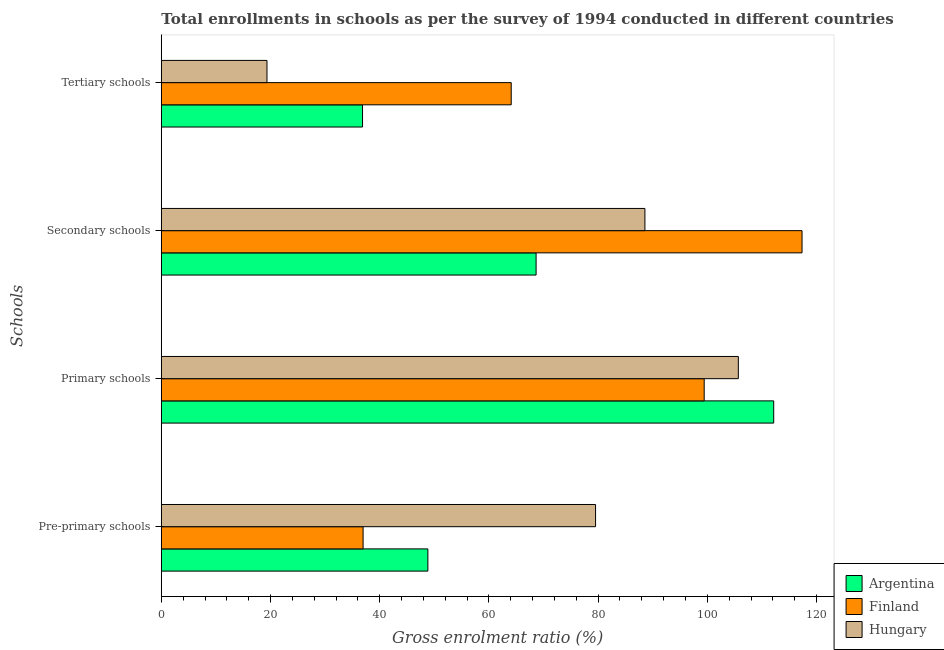How many different coloured bars are there?
Ensure brevity in your answer.  3. Are the number of bars per tick equal to the number of legend labels?
Your answer should be compact. Yes. How many bars are there on the 1st tick from the top?
Keep it short and to the point. 3. What is the label of the 4th group of bars from the top?
Offer a terse response. Pre-primary schools. What is the gross enrolment ratio in primary schools in Hungary?
Your answer should be compact. 105.68. Across all countries, what is the maximum gross enrolment ratio in primary schools?
Offer a terse response. 112.15. Across all countries, what is the minimum gross enrolment ratio in primary schools?
Your response must be concise. 99.42. In which country was the gross enrolment ratio in tertiary schools maximum?
Keep it short and to the point. Finland. In which country was the gross enrolment ratio in tertiary schools minimum?
Make the answer very short. Hungary. What is the total gross enrolment ratio in pre-primary schools in the graph?
Your response must be concise. 165.3. What is the difference between the gross enrolment ratio in tertiary schools in Finland and that in Hungary?
Make the answer very short. 44.73. What is the difference between the gross enrolment ratio in pre-primary schools in Hungary and the gross enrolment ratio in primary schools in Argentina?
Keep it short and to the point. -32.62. What is the average gross enrolment ratio in secondary schools per country?
Offer a terse response. 91.51. What is the difference between the gross enrolment ratio in secondary schools and gross enrolment ratio in pre-primary schools in Argentina?
Make the answer very short. 19.82. What is the ratio of the gross enrolment ratio in secondary schools in Hungary to that in Argentina?
Provide a short and direct response. 1.29. Is the difference between the gross enrolment ratio in primary schools in Finland and Hungary greater than the difference between the gross enrolment ratio in tertiary schools in Finland and Hungary?
Your answer should be compact. No. What is the difference between the highest and the second highest gross enrolment ratio in secondary schools?
Ensure brevity in your answer.  28.78. What is the difference between the highest and the lowest gross enrolment ratio in tertiary schools?
Give a very brief answer. 44.73. Is it the case that in every country, the sum of the gross enrolment ratio in pre-primary schools and gross enrolment ratio in secondary schools is greater than the sum of gross enrolment ratio in tertiary schools and gross enrolment ratio in primary schools?
Provide a succinct answer. Yes. What does the 3rd bar from the top in Pre-primary schools represents?
Keep it short and to the point. Argentina. What does the 1st bar from the bottom in Tertiary schools represents?
Offer a terse response. Argentina. How many bars are there?
Ensure brevity in your answer.  12. What is the difference between two consecutive major ticks on the X-axis?
Offer a very short reply. 20. Are the values on the major ticks of X-axis written in scientific E-notation?
Give a very brief answer. No. Does the graph contain any zero values?
Ensure brevity in your answer.  No. Does the graph contain grids?
Keep it short and to the point. No. How are the legend labels stacked?
Make the answer very short. Vertical. What is the title of the graph?
Provide a succinct answer. Total enrollments in schools as per the survey of 1994 conducted in different countries. Does "Middle East & North Africa (developing only)" appear as one of the legend labels in the graph?
Offer a very short reply. No. What is the label or title of the Y-axis?
Offer a terse response. Schools. What is the Gross enrolment ratio (%) in Argentina in Pre-primary schools?
Your response must be concise. 48.82. What is the Gross enrolment ratio (%) of Finland in Pre-primary schools?
Provide a short and direct response. 36.95. What is the Gross enrolment ratio (%) in Hungary in Pre-primary schools?
Your answer should be compact. 79.53. What is the Gross enrolment ratio (%) in Argentina in Primary schools?
Offer a very short reply. 112.15. What is the Gross enrolment ratio (%) of Finland in Primary schools?
Give a very brief answer. 99.42. What is the Gross enrolment ratio (%) in Hungary in Primary schools?
Offer a terse response. 105.68. What is the Gross enrolment ratio (%) in Argentina in Secondary schools?
Give a very brief answer. 68.64. What is the Gross enrolment ratio (%) of Finland in Secondary schools?
Your answer should be compact. 117.34. What is the Gross enrolment ratio (%) of Hungary in Secondary schools?
Offer a terse response. 88.56. What is the Gross enrolment ratio (%) in Argentina in Tertiary schools?
Your response must be concise. 36.85. What is the Gross enrolment ratio (%) of Finland in Tertiary schools?
Your answer should be compact. 64.08. What is the Gross enrolment ratio (%) of Hungary in Tertiary schools?
Provide a succinct answer. 19.35. Across all Schools, what is the maximum Gross enrolment ratio (%) in Argentina?
Offer a very short reply. 112.15. Across all Schools, what is the maximum Gross enrolment ratio (%) of Finland?
Your answer should be compact. 117.34. Across all Schools, what is the maximum Gross enrolment ratio (%) in Hungary?
Your answer should be very brief. 105.68. Across all Schools, what is the minimum Gross enrolment ratio (%) in Argentina?
Offer a very short reply. 36.85. Across all Schools, what is the minimum Gross enrolment ratio (%) in Finland?
Give a very brief answer. 36.95. Across all Schools, what is the minimum Gross enrolment ratio (%) of Hungary?
Provide a short and direct response. 19.35. What is the total Gross enrolment ratio (%) in Argentina in the graph?
Your answer should be very brief. 266.46. What is the total Gross enrolment ratio (%) of Finland in the graph?
Your answer should be very brief. 317.79. What is the total Gross enrolment ratio (%) in Hungary in the graph?
Your answer should be very brief. 293.12. What is the difference between the Gross enrolment ratio (%) in Argentina in Pre-primary schools and that in Primary schools?
Your answer should be compact. -63.33. What is the difference between the Gross enrolment ratio (%) of Finland in Pre-primary schools and that in Primary schools?
Offer a very short reply. -62.47. What is the difference between the Gross enrolment ratio (%) in Hungary in Pre-primary schools and that in Primary schools?
Ensure brevity in your answer.  -26.15. What is the difference between the Gross enrolment ratio (%) in Argentina in Pre-primary schools and that in Secondary schools?
Provide a short and direct response. -19.82. What is the difference between the Gross enrolment ratio (%) of Finland in Pre-primary schools and that in Secondary schools?
Offer a terse response. -80.39. What is the difference between the Gross enrolment ratio (%) of Hungary in Pre-primary schools and that in Secondary schools?
Offer a terse response. -9.04. What is the difference between the Gross enrolment ratio (%) of Argentina in Pre-primary schools and that in Tertiary schools?
Your response must be concise. 11.97. What is the difference between the Gross enrolment ratio (%) in Finland in Pre-primary schools and that in Tertiary schools?
Offer a very short reply. -27.13. What is the difference between the Gross enrolment ratio (%) in Hungary in Pre-primary schools and that in Tertiary schools?
Make the answer very short. 60.18. What is the difference between the Gross enrolment ratio (%) in Argentina in Primary schools and that in Secondary schools?
Your answer should be compact. 43.51. What is the difference between the Gross enrolment ratio (%) in Finland in Primary schools and that in Secondary schools?
Keep it short and to the point. -17.92. What is the difference between the Gross enrolment ratio (%) in Hungary in Primary schools and that in Secondary schools?
Offer a terse response. 17.11. What is the difference between the Gross enrolment ratio (%) in Argentina in Primary schools and that in Tertiary schools?
Keep it short and to the point. 75.3. What is the difference between the Gross enrolment ratio (%) of Finland in Primary schools and that in Tertiary schools?
Make the answer very short. 35.34. What is the difference between the Gross enrolment ratio (%) of Hungary in Primary schools and that in Tertiary schools?
Make the answer very short. 86.33. What is the difference between the Gross enrolment ratio (%) of Argentina in Secondary schools and that in Tertiary schools?
Your answer should be compact. 31.79. What is the difference between the Gross enrolment ratio (%) in Finland in Secondary schools and that in Tertiary schools?
Keep it short and to the point. 53.26. What is the difference between the Gross enrolment ratio (%) in Hungary in Secondary schools and that in Tertiary schools?
Your answer should be very brief. 69.21. What is the difference between the Gross enrolment ratio (%) of Argentina in Pre-primary schools and the Gross enrolment ratio (%) of Finland in Primary schools?
Ensure brevity in your answer.  -50.6. What is the difference between the Gross enrolment ratio (%) of Argentina in Pre-primary schools and the Gross enrolment ratio (%) of Hungary in Primary schools?
Provide a short and direct response. -56.86. What is the difference between the Gross enrolment ratio (%) of Finland in Pre-primary schools and the Gross enrolment ratio (%) of Hungary in Primary schools?
Provide a short and direct response. -68.72. What is the difference between the Gross enrolment ratio (%) in Argentina in Pre-primary schools and the Gross enrolment ratio (%) in Finland in Secondary schools?
Your response must be concise. -68.52. What is the difference between the Gross enrolment ratio (%) of Argentina in Pre-primary schools and the Gross enrolment ratio (%) of Hungary in Secondary schools?
Offer a very short reply. -39.75. What is the difference between the Gross enrolment ratio (%) in Finland in Pre-primary schools and the Gross enrolment ratio (%) in Hungary in Secondary schools?
Your answer should be compact. -51.61. What is the difference between the Gross enrolment ratio (%) in Argentina in Pre-primary schools and the Gross enrolment ratio (%) in Finland in Tertiary schools?
Make the answer very short. -15.26. What is the difference between the Gross enrolment ratio (%) in Argentina in Pre-primary schools and the Gross enrolment ratio (%) in Hungary in Tertiary schools?
Your answer should be compact. 29.47. What is the difference between the Gross enrolment ratio (%) in Finland in Pre-primary schools and the Gross enrolment ratio (%) in Hungary in Tertiary schools?
Provide a short and direct response. 17.6. What is the difference between the Gross enrolment ratio (%) in Argentina in Primary schools and the Gross enrolment ratio (%) in Finland in Secondary schools?
Provide a succinct answer. -5.19. What is the difference between the Gross enrolment ratio (%) in Argentina in Primary schools and the Gross enrolment ratio (%) in Hungary in Secondary schools?
Offer a terse response. 23.59. What is the difference between the Gross enrolment ratio (%) in Finland in Primary schools and the Gross enrolment ratio (%) in Hungary in Secondary schools?
Provide a short and direct response. 10.86. What is the difference between the Gross enrolment ratio (%) of Argentina in Primary schools and the Gross enrolment ratio (%) of Finland in Tertiary schools?
Make the answer very short. 48.07. What is the difference between the Gross enrolment ratio (%) in Argentina in Primary schools and the Gross enrolment ratio (%) in Hungary in Tertiary schools?
Make the answer very short. 92.8. What is the difference between the Gross enrolment ratio (%) in Finland in Primary schools and the Gross enrolment ratio (%) in Hungary in Tertiary schools?
Give a very brief answer. 80.07. What is the difference between the Gross enrolment ratio (%) in Argentina in Secondary schools and the Gross enrolment ratio (%) in Finland in Tertiary schools?
Ensure brevity in your answer.  4.56. What is the difference between the Gross enrolment ratio (%) of Argentina in Secondary schools and the Gross enrolment ratio (%) of Hungary in Tertiary schools?
Make the answer very short. 49.28. What is the difference between the Gross enrolment ratio (%) in Finland in Secondary schools and the Gross enrolment ratio (%) in Hungary in Tertiary schools?
Give a very brief answer. 97.99. What is the average Gross enrolment ratio (%) in Argentina per Schools?
Your response must be concise. 66.61. What is the average Gross enrolment ratio (%) of Finland per Schools?
Offer a terse response. 79.45. What is the average Gross enrolment ratio (%) in Hungary per Schools?
Provide a short and direct response. 73.28. What is the difference between the Gross enrolment ratio (%) in Argentina and Gross enrolment ratio (%) in Finland in Pre-primary schools?
Your response must be concise. 11.87. What is the difference between the Gross enrolment ratio (%) of Argentina and Gross enrolment ratio (%) of Hungary in Pre-primary schools?
Give a very brief answer. -30.71. What is the difference between the Gross enrolment ratio (%) in Finland and Gross enrolment ratio (%) in Hungary in Pre-primary schools?
Give a very brief answer. -42.58. What is the difference between the Gross enrolment ratio (%) in Argentina and Gross enrolment ratio (%) in Finland in Primary schools?
Keep it short and to the point. 12.73. What is the difference between the Gross enrolment ratio (%) of Argentina and Gross enrolment ratio (%) of Hungary in Primary schools?
Offer a very short reply. 6.47. What is the difference between the Gross enrolment ratio (%) of Finland and Gross enrolment ratio (%) of Hungary in Primary schools?
Make the answer very short. -6.26. What is the difference between the Gross enrolment ratio (%) in Argentina and Gross enrolment ratio (%) in Finland in Secondary schools?
Give a very brief answer. -48.7. What is the difference between the Gross enrolment ratio (%) of Argentina and Gross enrolment ratio (%) of Hungary in Secondary schools?
Your answer should be compact. -19.93. What is the difference between the Gross enrolment ratio (%) of Finland and Gross enrolment ratio (%) of Hungary in Secondary schools?
Give a very brief answer. 28.78. What is the difference between the Gross enrolment ratio (%) of Argentina and Gross enrolment ratio (%) of Finland in Tertiary schools?
Give a very brief answer. -27.23. What is the difference between the Gross enrolment ratio (%) of Argentina and Gross enrolment ratio (%) of Hungary in Tertiary schools?
Your answer should be very brief. 17.5. What is the difference between the Gross enrolment ratio (%) of Finland and Gross enrolment ratio (%) of Hungary in Tertiary schools?
Ensure brevity in your answer.  44.73. What is the ratio of the Gross enrolment ratio (%) of Argentina in Pre-primary schools to that in Primary schools?
Your answer should be very brief. 0.44. What is the ratio of the Gross enrolment ratio (%) in Finland in Pre-primary schools to that in Primary schools?
Your answer should be compact. 0.37. What is the ratio of the Gross enrolment ratio (%) in Hungary in Pre-primary schools to that in Primary schools?
Offer a terse response. 0.75. What is the ratio of the Gross enrolment ratio (%) of Argentina in Pre-primary schools to that in Secondary schools?
Your answer should be very brief. 0.71. What is the ratio of the Gross enrolment ratio (%) in Finland in Pre-primary schools to that in Secondary schools?
Your response must be concise. 0.31. What is the ratio of the Gross enrolment ratio (%) of Hungary in Pre-primary schools to that in Secondary schools?
Give a very brief answer. 0.9. What is the ratio of the Gross enrolment ratio (%) in Argentina in Pre-primary schools to that in Tertiary schools?
Your response must be concise. 1.32. What is the ratio of the Gross enrolment ratio (%) of Finland in Pre-primary schools to that in Tertiary schools?
Give a very brief answer. 0.58. What is the ratio of the Gross enrolment ratio (%) in Hungary in Pre-primary schools to that in Tertiary schools?
Your response must be concise. 4.11. What is the ratio of the Gross enrolment ratio (%) of Argentina in Primary schools to that in Secondary schools?
Provide a short and direct response. 1.63. What is the ratio of the Gross enrolment ratio (%) in Finland in Primary schools to that in Secondary schools?
Your answer should be compact. 0.85. What is the ratio of the Gross enrolment ratio (%) of Hungary in Primary schools to that in Secondary schools?
Give a very brief answer. 1.19. What is the ratio of the Gross enrolment ratio (%) in Argentina in Primary schools to that in Tertiary schools?
Offer a very short reply. 3.04. What is the ratio of the Gross enrolment ratio (%) in Finland in Primary schools to that in Tertiary schools?
Your answer should be very brief. 1.55. What is the ratio of the Gross enrolment ratio (%) of Hungary in Primary schools to that in Tertiary schools?
Make the answer very short. 5.46. What is the ratio of the Gross enrolment ratio (%) in Argentina in Secondary schools to that in Tertiary schools?
Provide a succinct answer. 1.86. What is the ratio of the Gross enrolment ratio (%) of Finland in Secondary schools to that in Tertiary schools?
Provide a short and direct response. 1.83. What is the ratio of the Gross enrolment ratio (%) in Hungary in Secondary schools to that in Tertiary schools?
Provide a short and direct response. 4.58. What is the difference between the highest and the second highest Gross enrolment ratio (%) in Argentina?
Keep it short and to the point. 43.51. What is the difference between the highest and the second highest Gross enrolment ratio (%) of Finland?
Keep it short and to the point. 17.92. What is the difference between the highest and the second highest Gross enrolment ratio (%) in Hungary?
Your response must be concise. 17.11. What is the difference between the highest and the lowest Gross enrolment ratio (%) of Argentina?
Provide a short and direct response. 75.3. What is the difference between the highest and the lowest Gross enrolment ratio (%) of Finland?
Give a very brief answer. 80.39. What is the difference between the highest and the lowest Gross enrolment ratio (%) in Hungary?
Give a very brief answer. 86.33. 